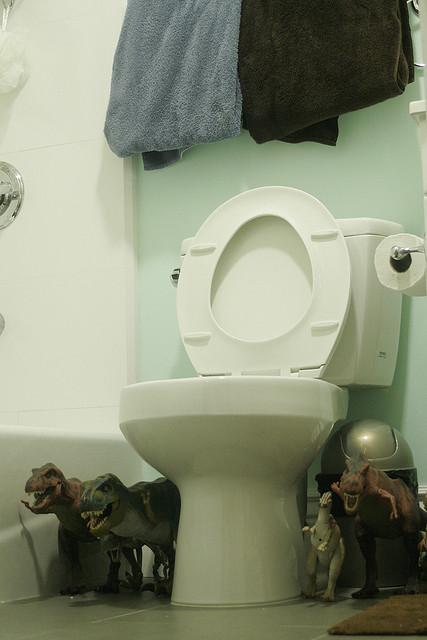Does this bathroom look comfortable?
Give a very brief answer. No. Is the toilet clean?
Answer briefly. Yes. Is this a child's bathroom?
Quick response, please. Yes. What is the gender of the person that used the bathroom last?
Concise answer only. Male. What animal is shown?
Concise answer only. Dinosaur. What color is the wall?
Keep it brief. White. 